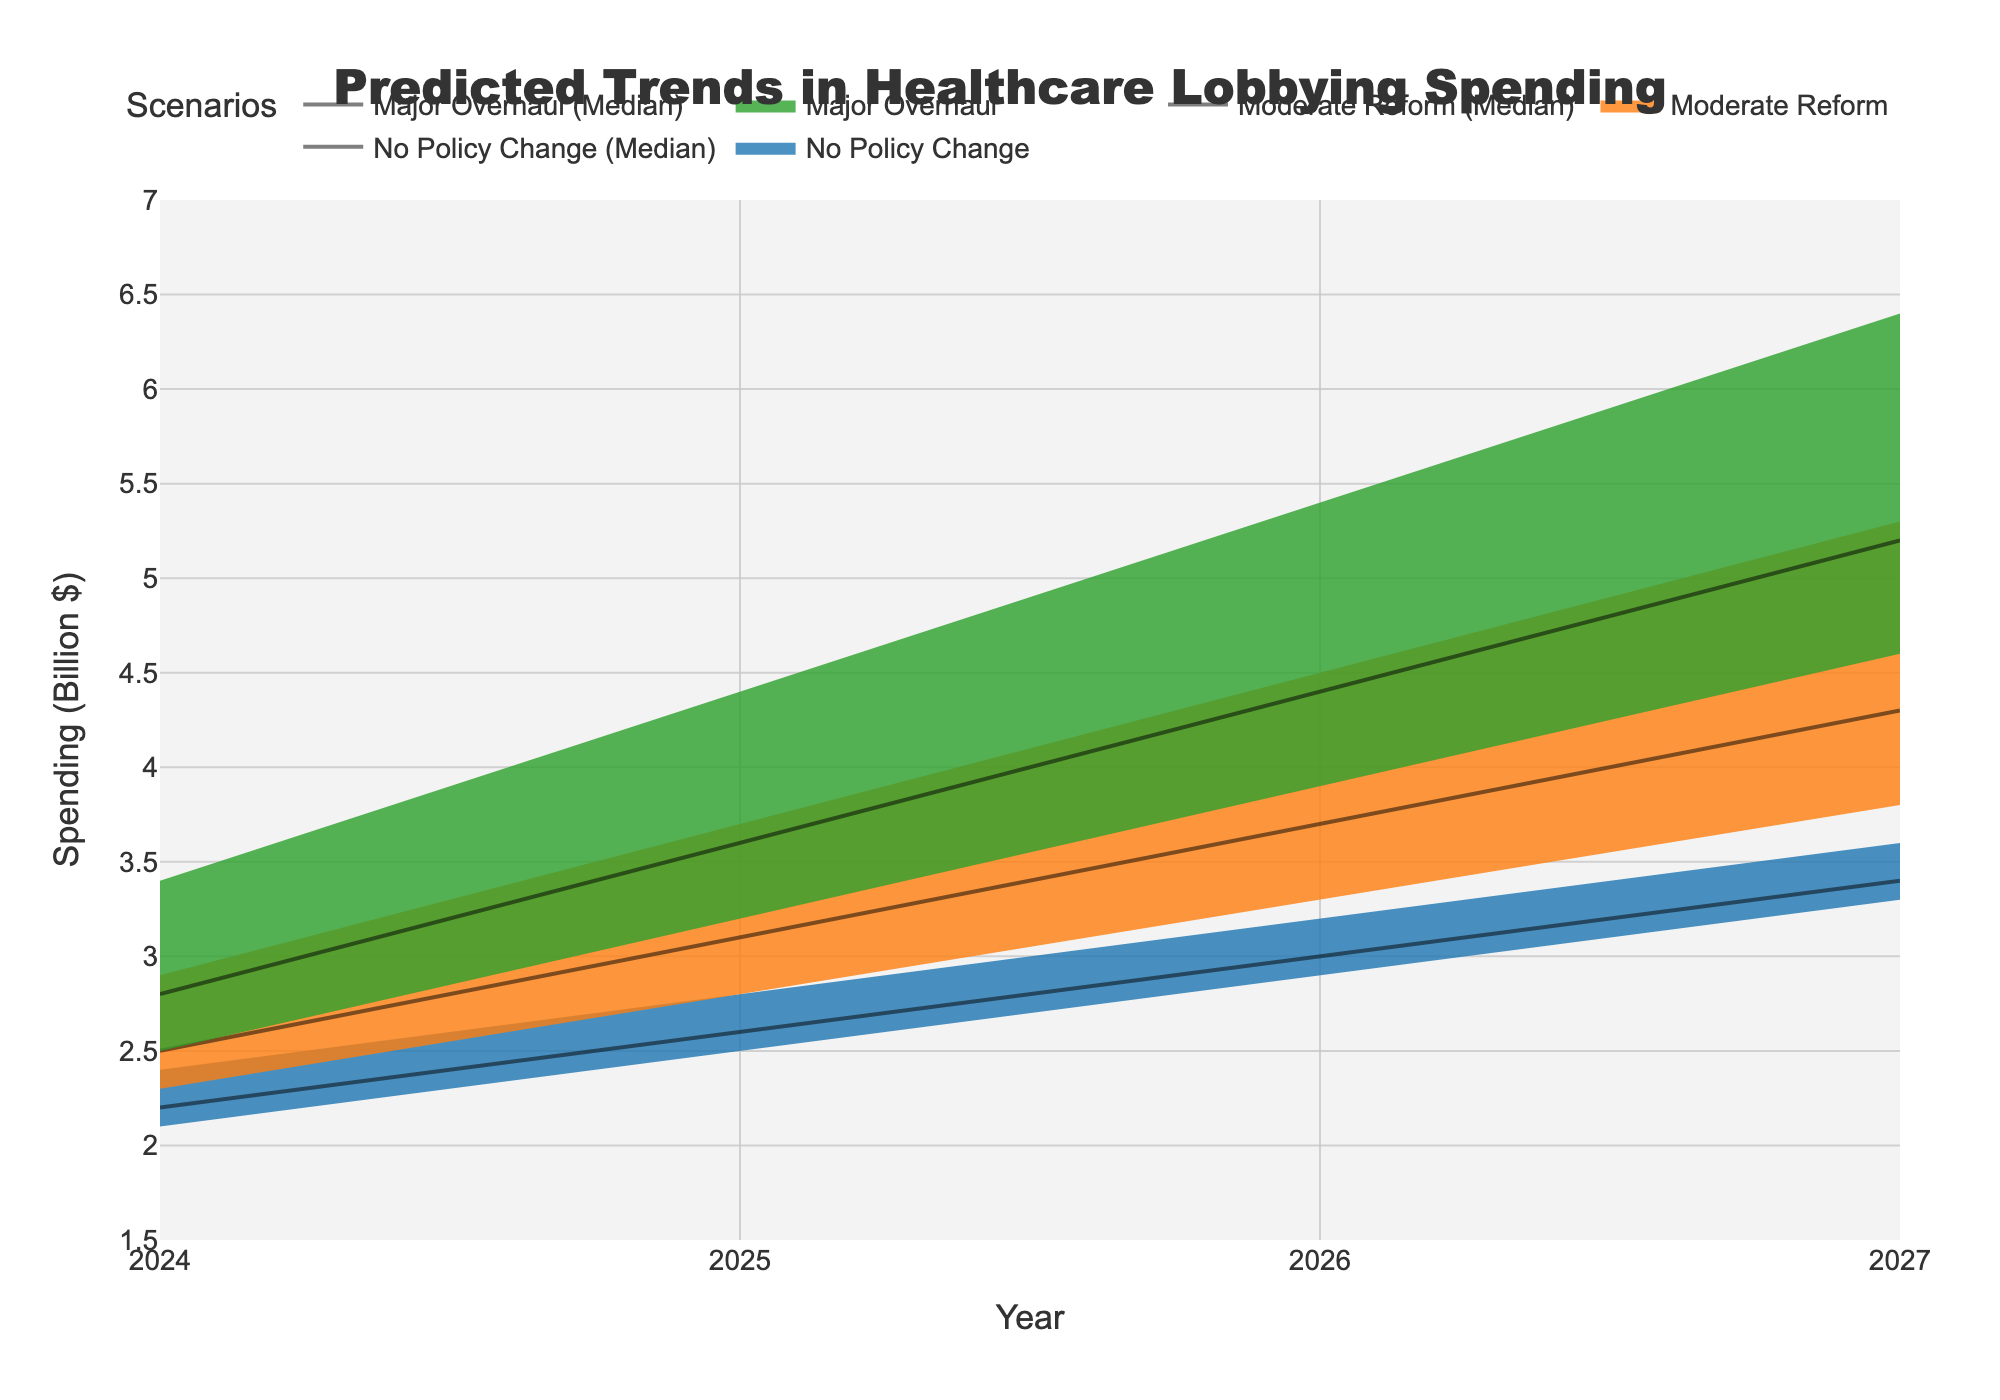What is the title of the figure? The title of the figure is located at the top center of the chart. It summarizes the main content presented in the figure.
Answer: Predicted Trends in Healthcare Lobbying Spending What does the x-axis represent? The x-axis is labeled at the bottom of the chart, indicating what is being measured along this axis.
Answer: Year What does the y-axis represent? The y-axis is labeled along the left side of the chart, indicating what is being measured along this axis.
Answer: Spending (Billion $) Which scenario shows the highest median spending in 2027? Find the median spending for each scenario by locating their respective lines at 2027 and comparing them.
Answer: Major Overhaul In 2025, what is the range of healthcare lobbying spending under the scenario of Major Overhaul? Look at the Q1 (lowest) and Q4 (highest) values for the Major Overhaul scenario in the year 2025. The range is the difference between Q4 and Q1.
Answer: 3.2 to 4.4 Billion $ How does the median spending change from 2024 to 2027 for the scenario with no policy change? Track the median spending line for the No Policy Change scenario from 2024 to 2027. Observe the increase in values across these years.
Answer: 2.2 Billion $ to 3.4 Billion $ By how much does the median spending increase from 2024 to 2026 for Moderate Reform? Find the median values for the Moderate Reform scenario in 2024 and 2026. Subtract the 2024 value from the 2026 value.
Answer: 1.2 Billion $ Which scenario has the widest range of predicted values (Q1 to Q4) in 2026? Compare the ranges (Q1 to Q4) of spending for each scenario in 2026 to find the widest one.
Answer: Major Overhaul Which year is predicted to have the lowest median spending for Moderate Reform? Identify the median spending values for the Moderate Reform scenario across all years and find the year with the lowest value.
Answer: 2024 